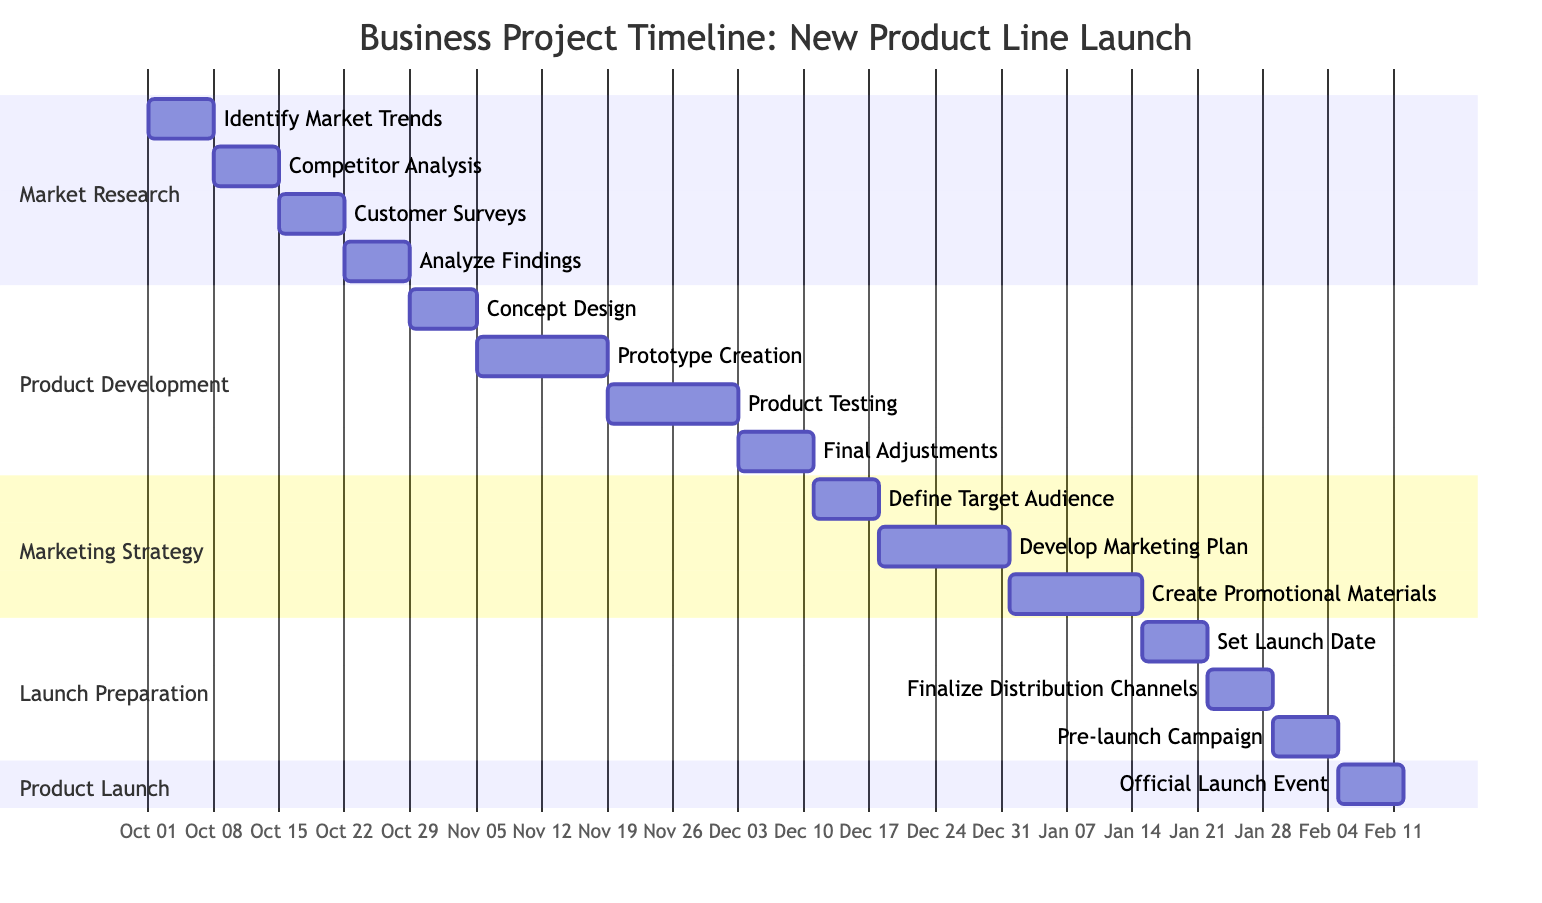What is the total duration of the Market Research phase? The Market Research phase has a defined duration of 4 weeks. This is directly indicated in the section header of the Gantt Chart.
Answer: 4 weeks How many tasks are included in the Product Development phase? The Product Development phase includes four tasks: Concept Design, Prototype Creation, Product Testing, and Final Adjustments, which can be counted in the designated section of the Gantt Chart.
Answer: 4 tasks Which task follows the Customer Surveys in the timeline? After Customer Surveys, the next task is Analyze Findings, as indicated by the order of tasks listed under the Market Research section of the Gantt Chart.
Answer: Analyze Findings What is the start date of the final task in the Launch Preparation phase? The last task in the Launch Preparation phase is Pre-launch Campaign, which starts on January 29, 2024, as shown in the corresponding section of the Gantt Chart.
Answer: January 29, 2024 How long does the Marketing Strategy phase last in days? The Marketing Strategy phase lasts 6 weeks, which converts to 42 days when calculated (6 weeks x 7 days/week). The total duration is noted in the phase header.
Answer: 42 days Which phase directly precedes the Product Launch phase? The phase that comes directly before the Product Launch phase is Launch Preparation, as this sequence is clearly defined in the Gantt Chart's layout.
Answer: Launch Preparation What is the duration of the Product Launch phase? The Product Launch phase has a duration of 1 week, which is stated in the section header of the Gantt Chart.
Answer: 1 week What task is scheduled to take place during the week of December 3 to December 10, 2023? During this week, the task scheduled is Final Adjustments as indicated by the dates next to the task in the Product Development section of the Gantt Chart.
Answer: Final Adjustments During which weeks does the Prototype Creation task occur? The Prototype Creation task occurs from November 5 to November 18, 2023, as shown by the start and end dates associated with this task in the Gantt Chart.
Answer: November 5 to November 18, 2023 